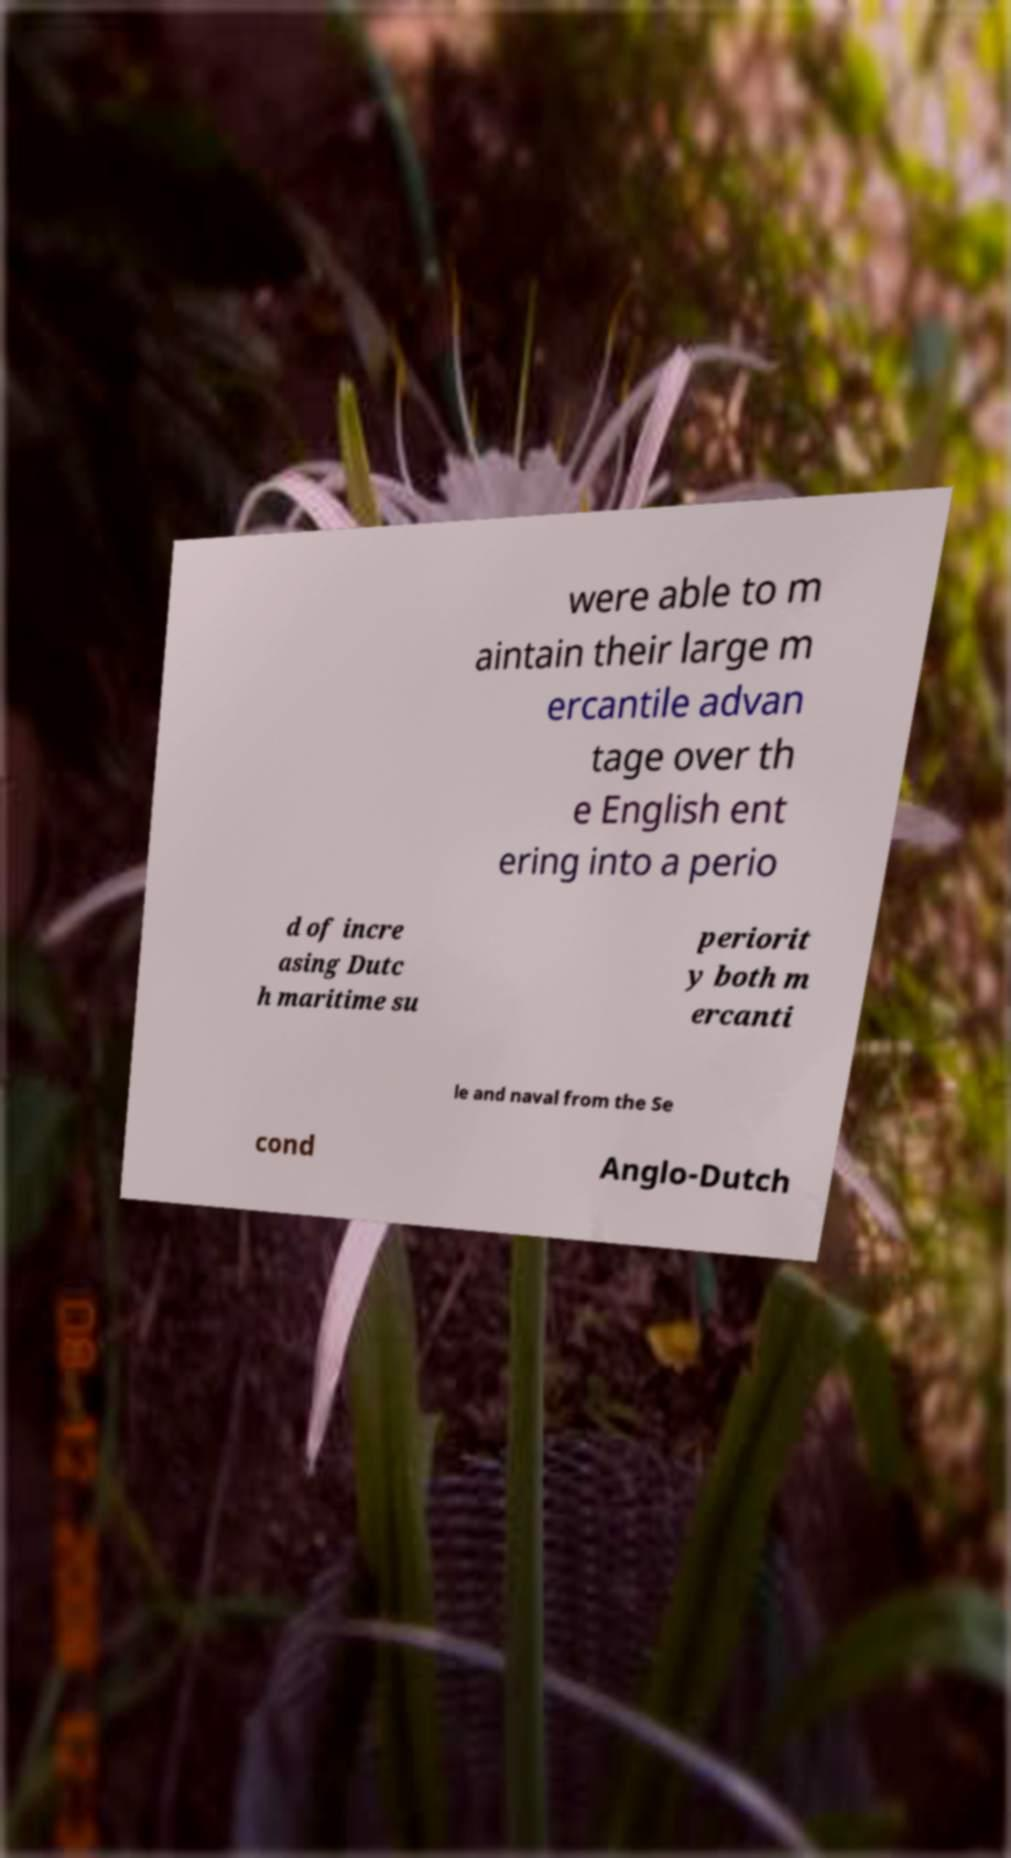Please identify and transcribe the text found in this image. were able to m aintain their large m ercantile advan tage over th e English ent ering into a perio d of incre asing Dutc h maritime su periorit y both m ercanti le and naval from the Se cond Anglo-Dutch 